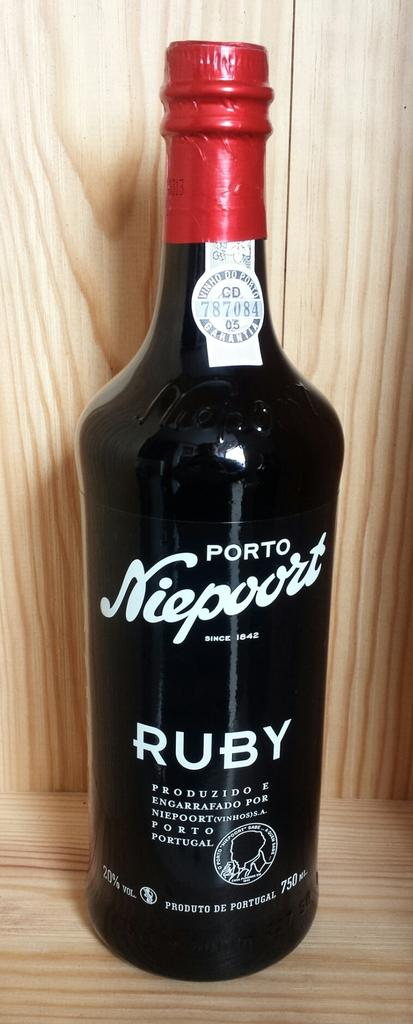<image>
Offer a succinct explanation of the picture presented. A bottle of Porto Niepoort wine on a wooden shelf. 